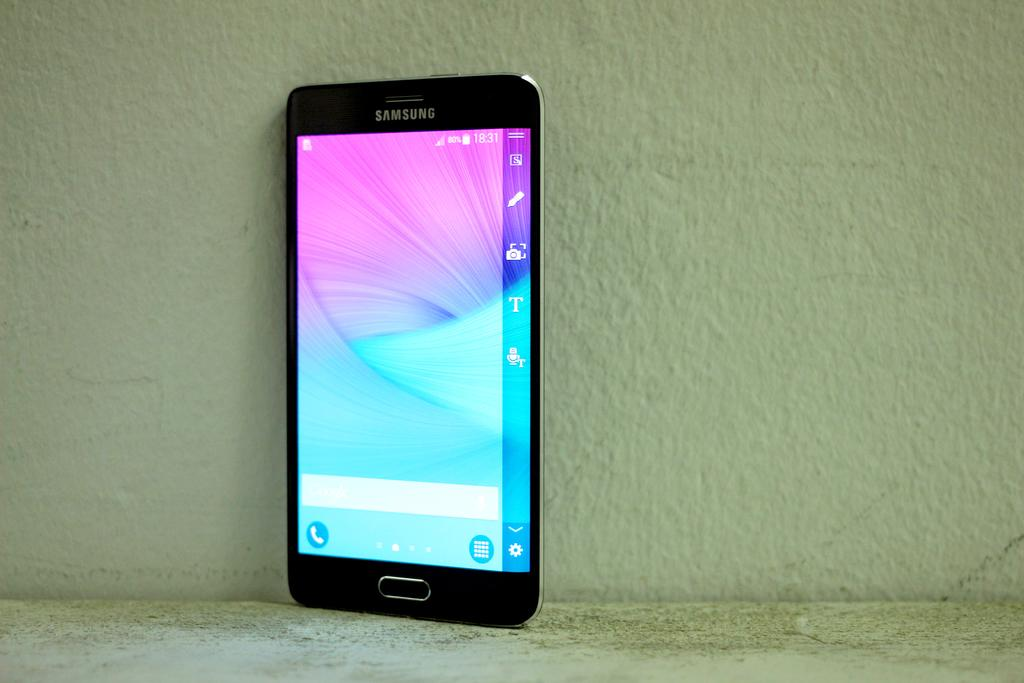What electronic device is visible in the image? There is a mobile phone in the image. What can be seen in the background of the image? There is a wall in the background of the image. What feature does the mobile phone have? The mobile phone has a screen and a button. What type of rod is being used to measure the growth of the doll in the image? There is no rod or doll present in the image; it only features a mobile phone and a wall in the background. 